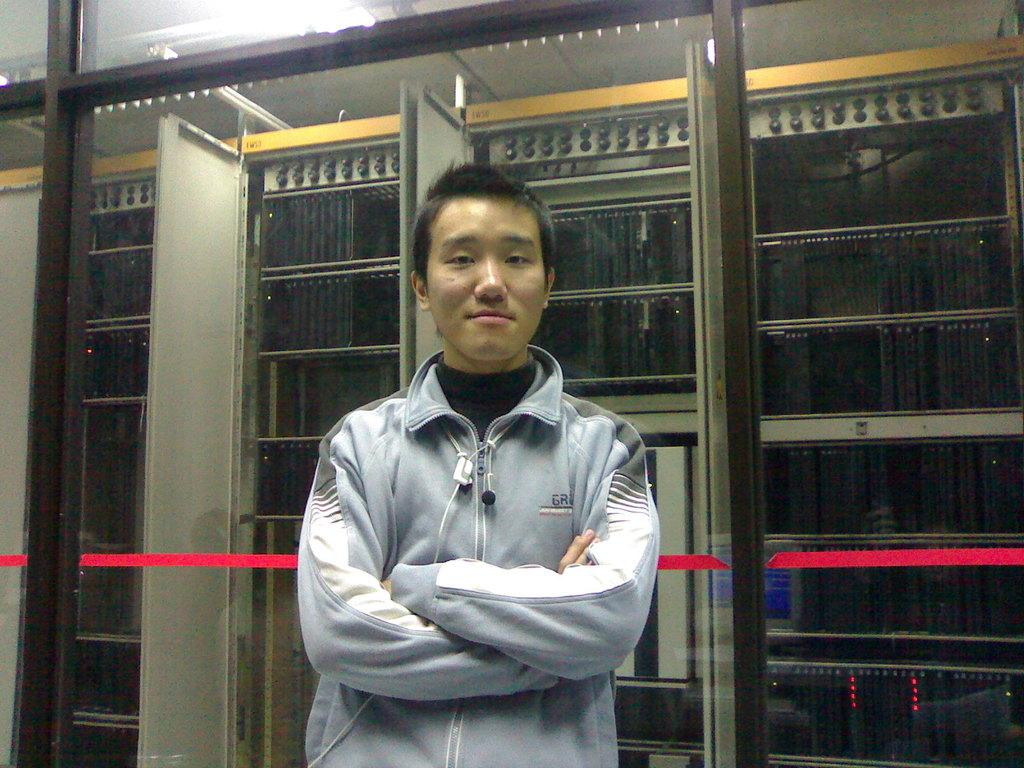What is the main subject of the image? There is a man standing in the image. What can be seen in the background of the image? There is a glass wall in the background of the image. What is located behind the glass wall? Machines are visible behind the glass wall. What is the source of light in the image? There is a light at the top of the image. What does the man's ear look like in the image? The image does not show the man's ear, so it cannot be described. 